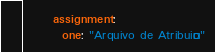Convert code to text. <code><loc_0><loc_0><loc_500><loc_500><_YAML_>      assignment:
        one: "Arquivo de Atribuição"
</code> 